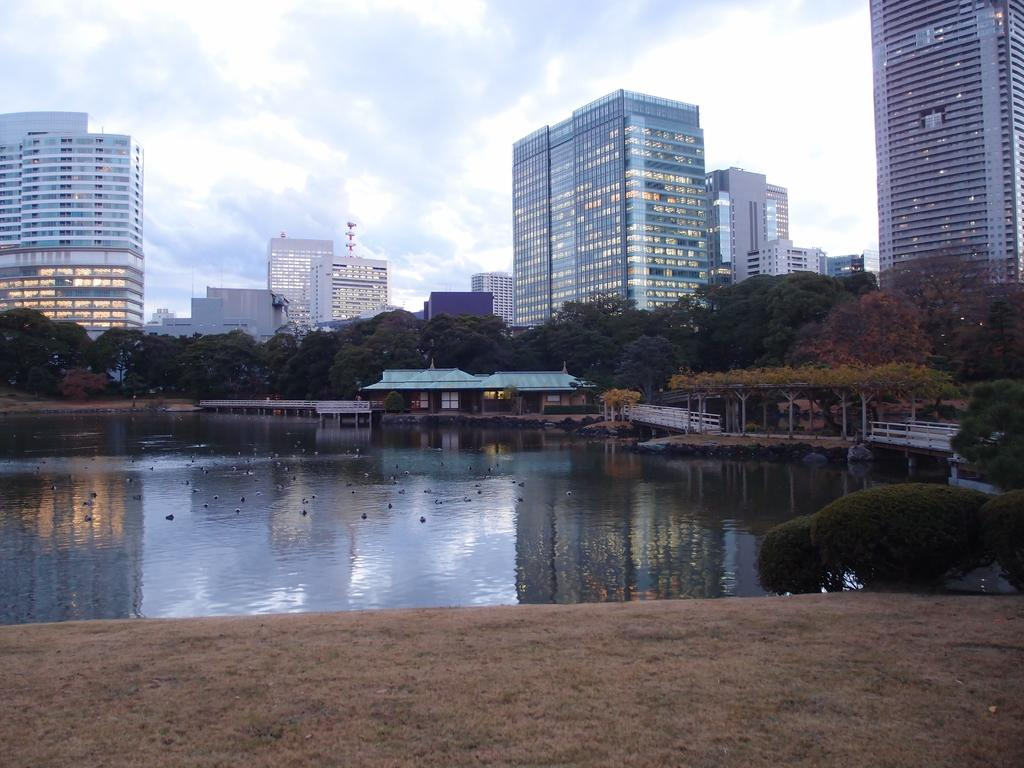What type of structures can be seen in the image? There are buildings in the image. What other natural elements are present in the image? There are trees and water visible in the image. How would you describe the sky in the image? The sky is blue and cloudy in the image. What hobbies are the trees participating in during recess in the image? There are no trees or recess present in the image; it features buildings, trees, water, and a blue and cloudy sky. 